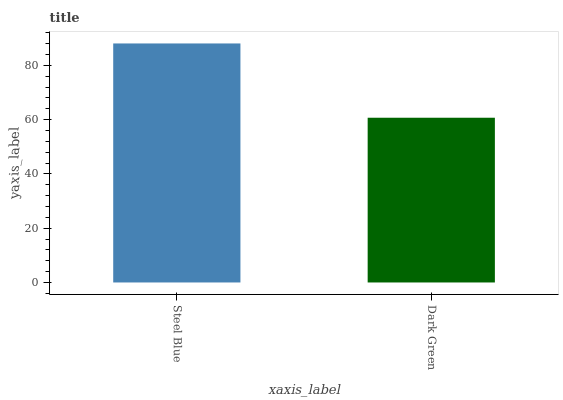Is Dark Green the maximum?
Answer yes or no. No. Is Steel Blue greater than Dark Green?
Answer yes or no. Yes. Is Dark Green less than Steel Blue?
Answer yes or no. Yes. Is Dark Green greater than Steel Blue?
Answer yes or no. No. Is Steel Blue less than Dark Green?
Answer yes or no. No. Is Steel Blue the high median?
Answer yes or no. Yes. Is Dark Green the low median?
Answer yes or no. Yes. Is Dark Green the high median?
Answer yes or no. No. Is Steel Blue the low median?
Answer yes or no. No. 